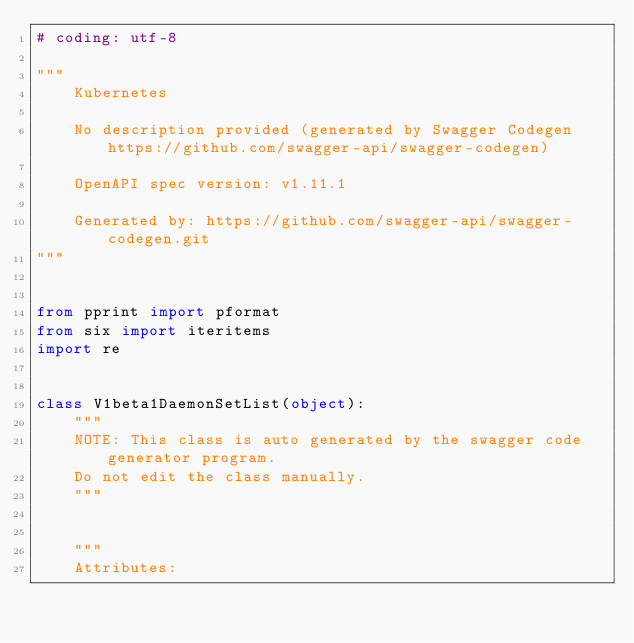Convert code to text. <code><loc_0><loc_0><loc_500><loc_500><_Python_># coding: utf-8

"""
    Kubernetes

    No description provided (generated by Swagger Codegen https://github.com/swagger-api/swagger-codegen)

    OpenAPI spec version: v1.11.1
    
    Generated by: https://github.com/swagger-api/swagger-codegen.git
"""


from pprint import pformat
from six import iteritems
import re


class V1beta1DaemonSetList(object):
    """
    NOTE: This class is auto generated by the swagger code generator program.
    Do not edit the class manually.
    """


    """
    Attributes:</code> 